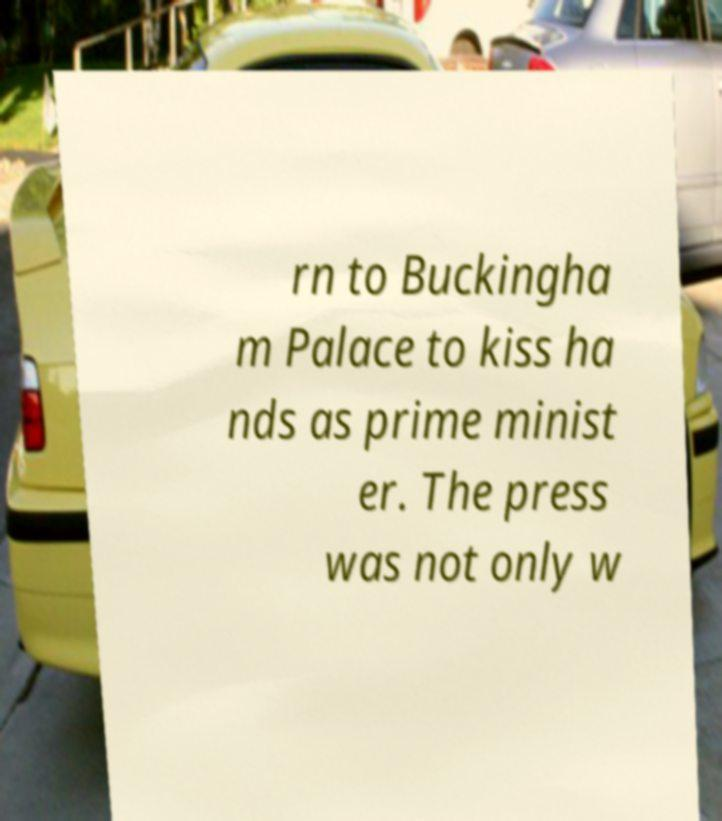Can you read and provide the text displayed in the image?This photo seems to have some interesting text. Can you extract and type it out for me? rn to Buckingha m Palace to kiss ha nds as prime minist er. The press was not only w 